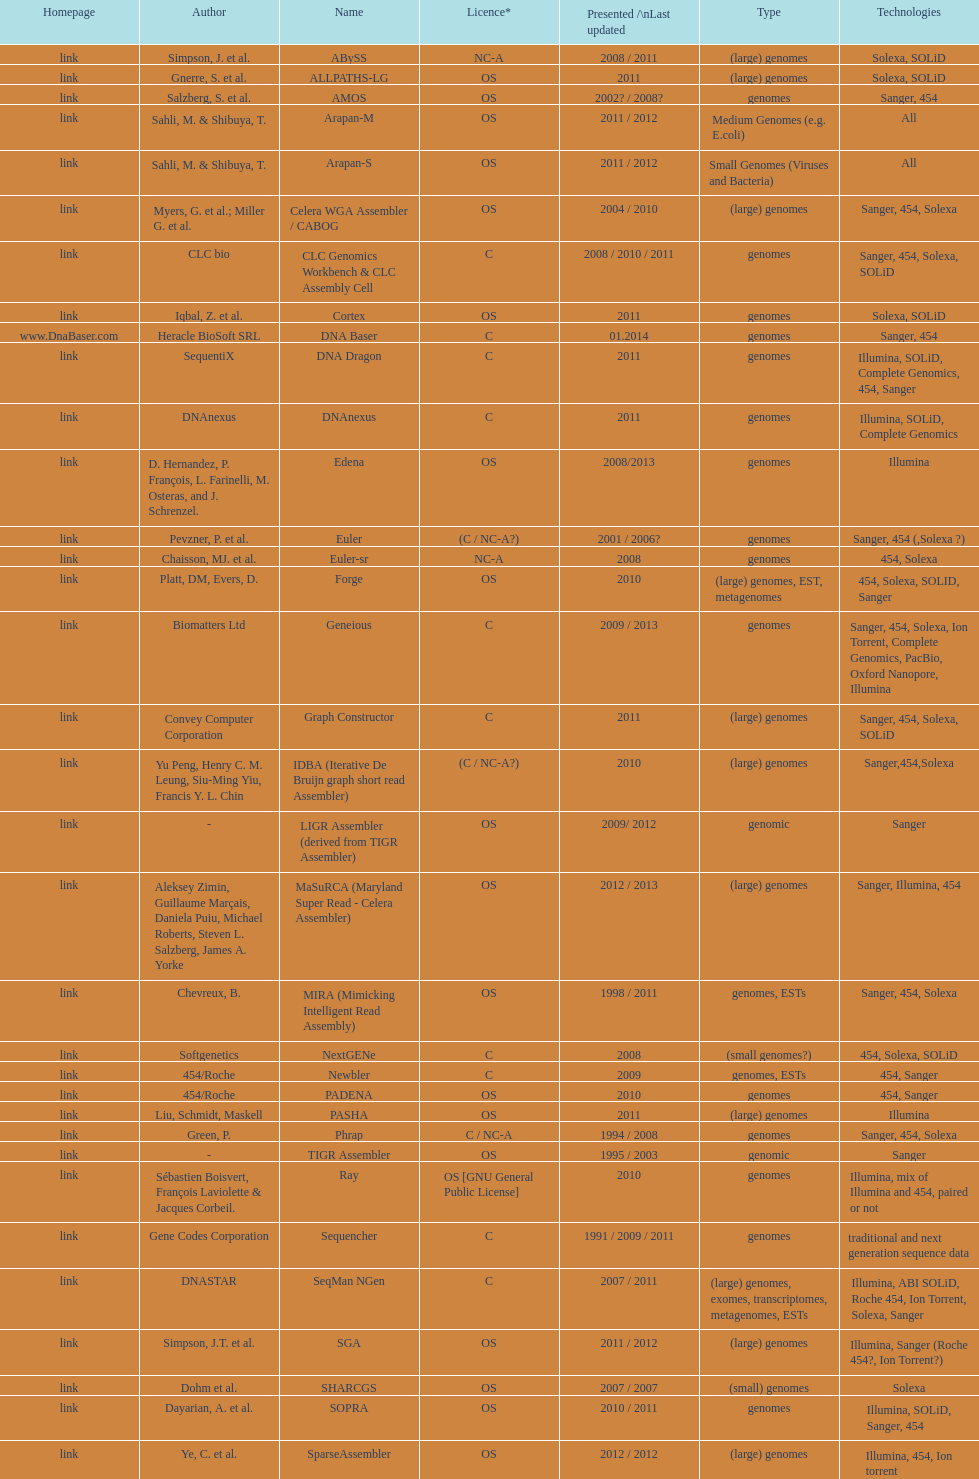What is the newest presentation or updated? DNA Baser. 